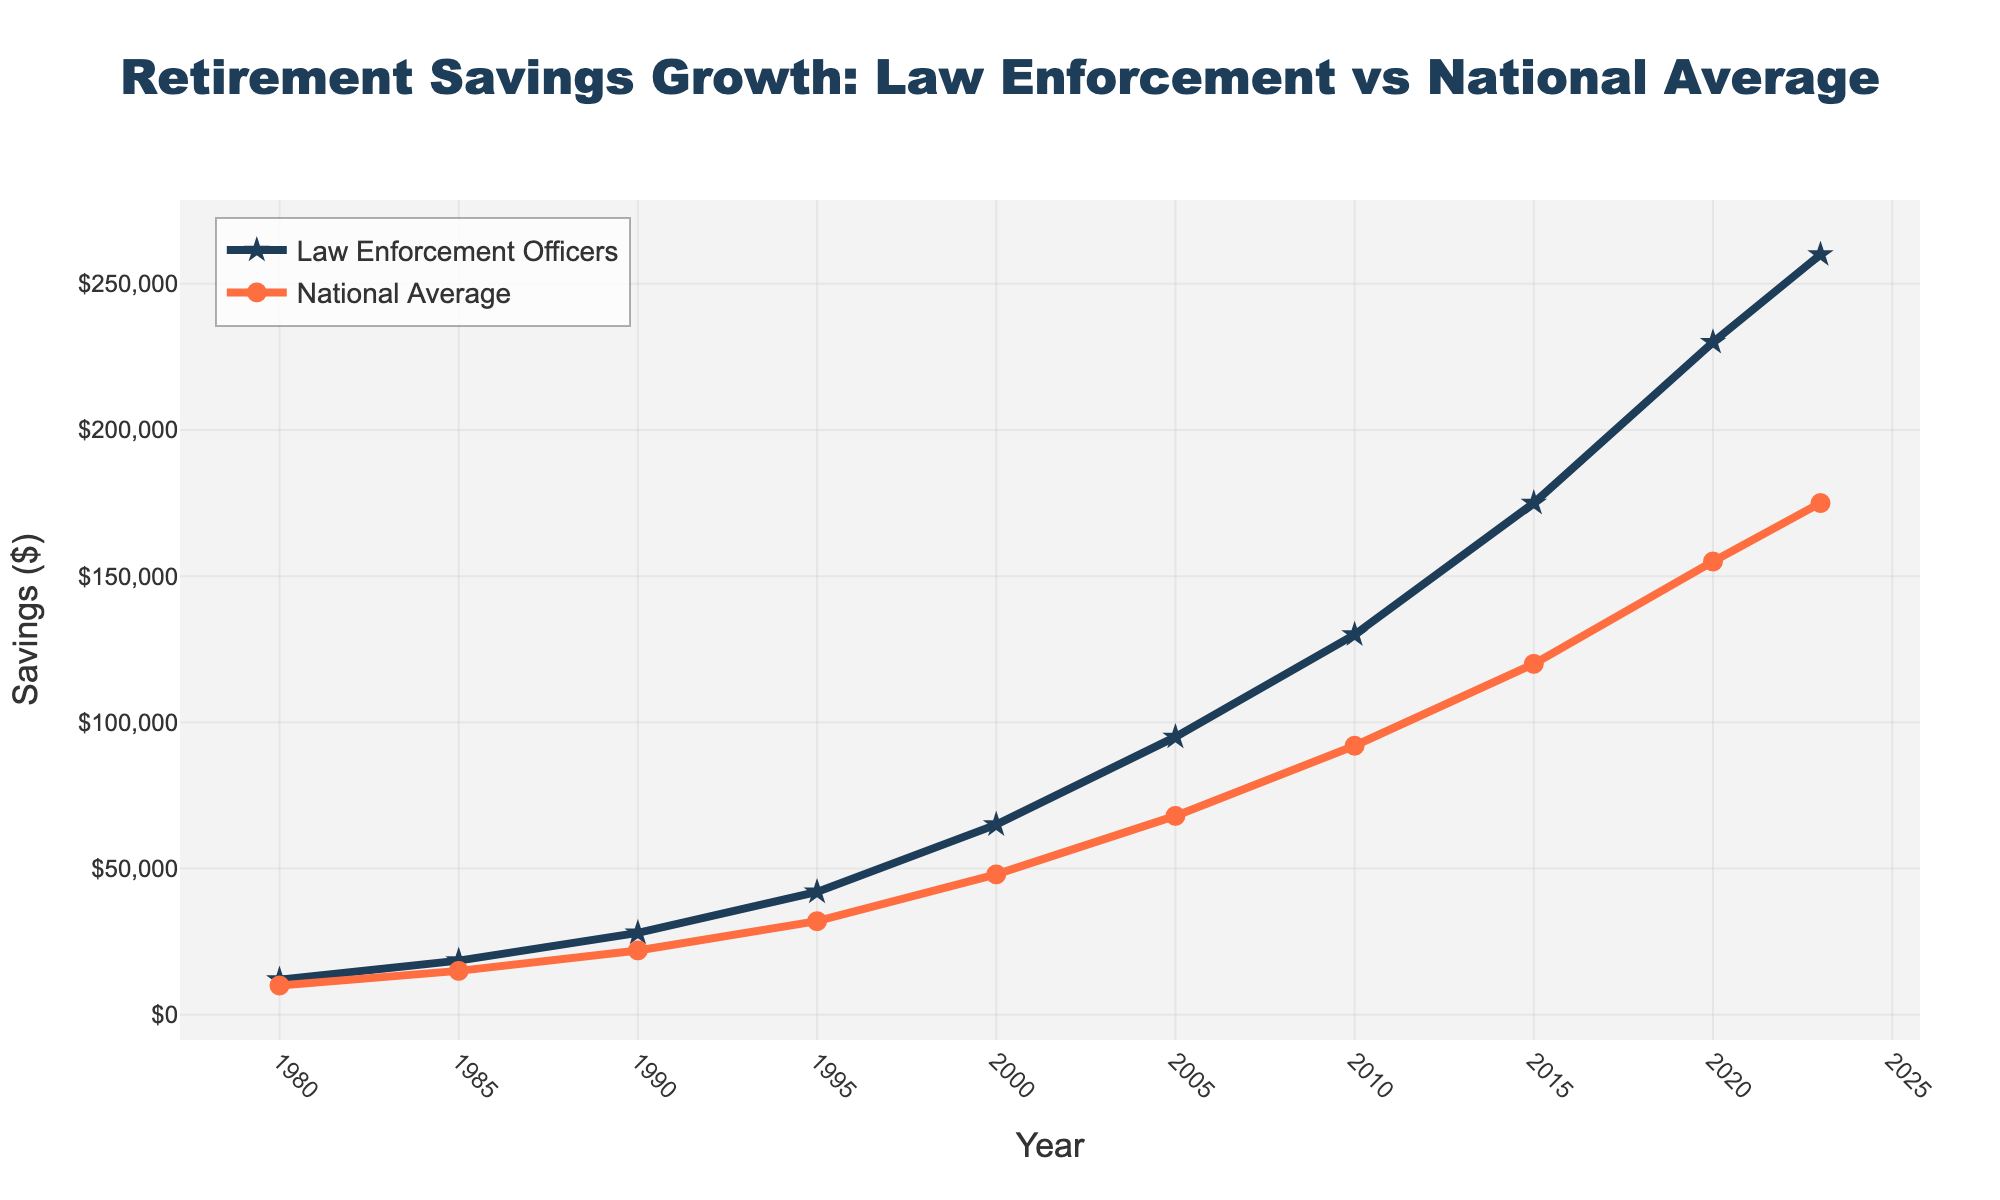What was the retirement savings for Law Enforcement Officers in 1995? Refer to the data points on the chart for 1995 and look at the value for Law Enforcement Officers. It shows a value of $42,000.
Answer: $42,000 Did the retirement savings for Law Enforcement Officers ever fall below the National Average during 1980-2023? By looking at the two lines in the chart, the Law Enforcement Officers' savings are always above the National Average from 1980 to 2023.
Answer: No Which year shows the largest difference in retirement savings between Law Enforcement Officers and the National Average? To find the largest difference, identify the two curves with the greatest vertical separation. In 2023, Law Enforcement Officers have $260,000 and the National Average has $175,000; The difference is $85,000.
Answer: 2023 What's the average retirement savings for the National Average from 1980 to 2023? First, sum the savings for these years: 
10000 + 15000 + 22000 + 32000 + 48000 + 68000 + 92000 + 120000 + 155000 + 175000 = 727000. Then divide by the number of data points, 10: 727000 / 10 = 72700.
Answer: $72,700 How did the Law Enforcement Officers' retirement savings change from 1980 to 2000? Look at the value in 1980 ($12,000) and compare it to the value in 2000 ($65,000). Calculate the difference: $65,000 - $12,000 = $53,000.
Answer: Increased by $53,000 In which year did the Law Enforcement Officers' retirement savings surpass $150,000? By tracking the line for Law Enforcement Officers' savings, it first surpasses $150,000 in 2015, reaching $175,000.
Answer: 2015 Is the growth rate of retirement savings for Law Enforcement Officers higher or lower than the National Average between 1980 and 2023? By comparing the slopes of the two lines from 1980 to 2023, the Law Enforcement Officers' line has a steeper slope indicating a higher growth rate.
Answer: Higher What is the difference in retirement savings between Law Enforcement Officers and the National Average in 1985? The data points for 1985 are: Law Enforcement Officers ($18,500) and National Average ($15,000). Calculate the difference: $18,500 - $15,000 = $3,500.
Answer: $3,500 What's the percentage increase in retirement savings for National Average from 2000 to 2023? Savings in 2000 were $48,000, and in 2023, they are $175,000. Calculate the increase: $175,000 - $48,000 = $127,000. Then, compute the percentage: ($127,000 / $48,000) * 100 ≈ 264.58%.
Answer: Approximately 265% Which line color represents the National Average on the chart? From the visual attributes of the lines in the chart, the National Average is represented by the orange line.
Answer: Orange 